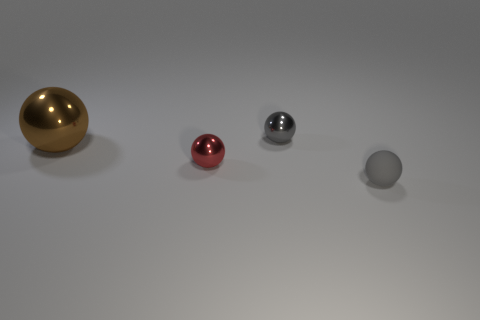Subtract all tiny gray rubber spheres. How many spheres are left? 3 Add 1 big shiny spheres. How many objects exist? 5 Subtract all gray blocks. How many gray balls are left? 2 Subtract all brown balls. How many balls are left? 3 Subtract 2 balls. How many balls are left? 2 Add 4 tiny gray balls. How many tiny gray balls exist? 6 Subtract 0 yellow blocks. How many objects are left? 4 Subtract all blue balls. Subtract all yellow cylinders. How many balls are left? 4 Subtract all tiny gray rubber balls. Subtract all tiny matte things. How many objects are left? 2 Add 3 large brown metal balls. How many large brown metal balls are left? 4 